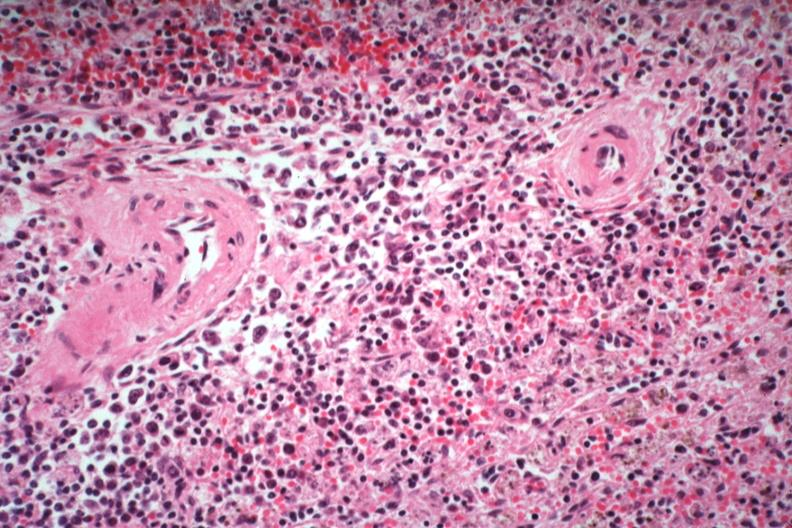what does this image show?
Answer the question using a single word or phrase. Immunoblastic type cells near splenic arteriole man died of what was thought to be viral pneumonia probably influenza 